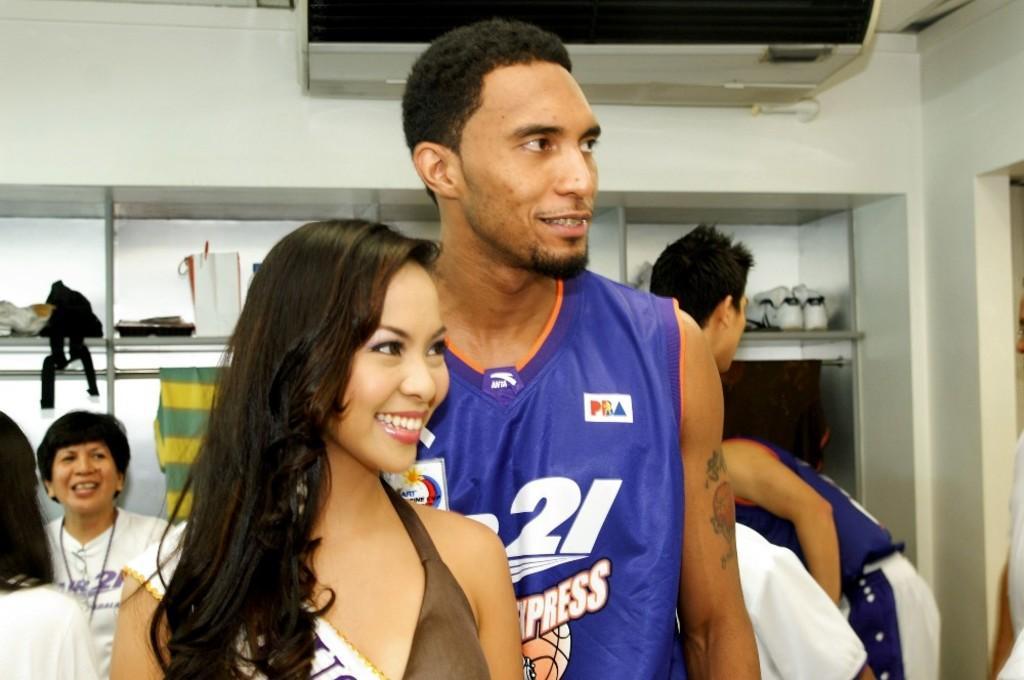How would you summarize this image in a sentence or two? In this image in the foreground there are persons standing and smiling. In the background there are persons, there is a shelf and on the shelf there are shoes and there are objects which are black and white in colour and there is a cloth hanging. On the right side there is an object which is brown in colour, which is hanging in the shelf and there is a wall which is white in colour. 